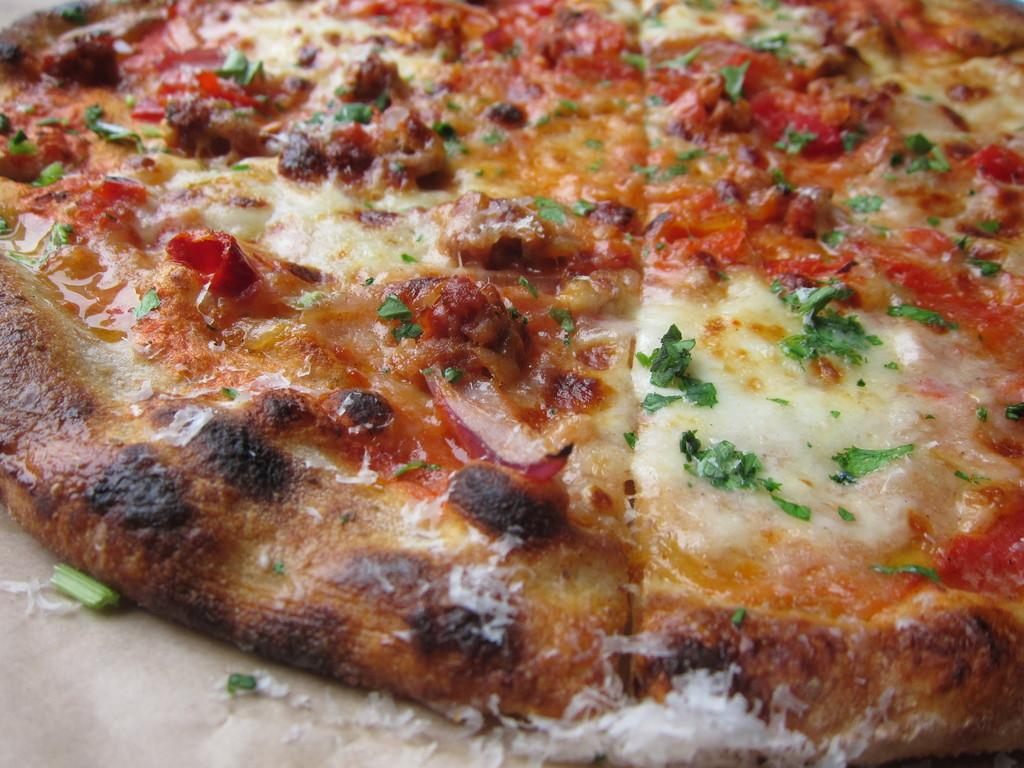What type of food is shown in the image? There is a pizza in the image. Where is the pizza located? The pizza is on a platform. What type of honey is drizzled on top of the pizza in the image? There is no honey present on the pizza in the image. 